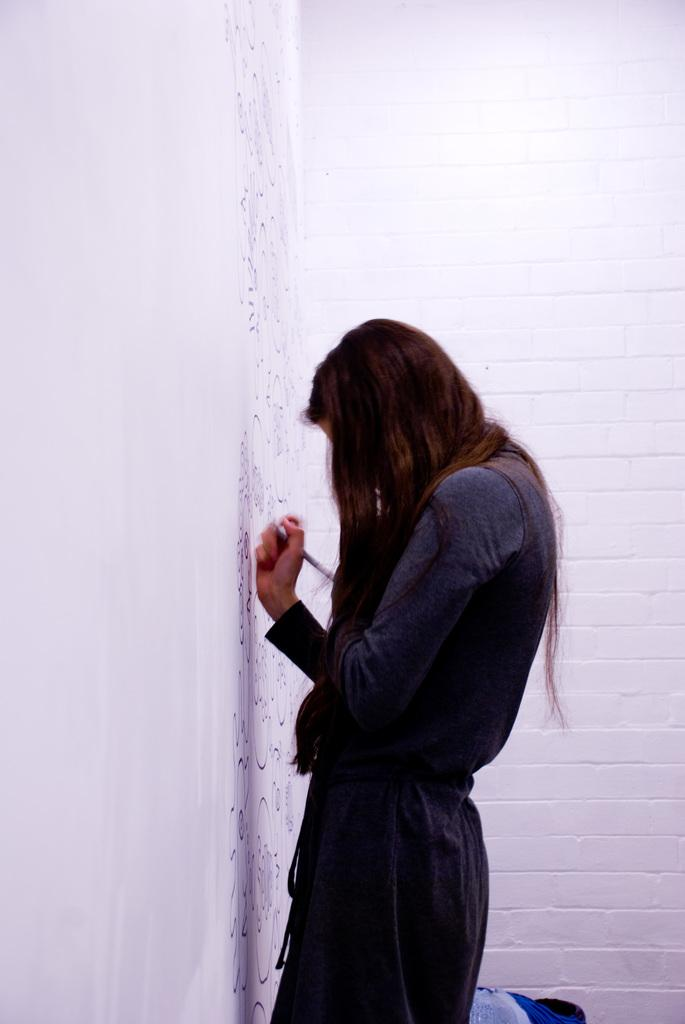Who is present in the image? There is a woman in the image. What is the woman doing in the image? The woman is standing at a wall and holding a pen. What can be seen in the background of the image? There is a wall in the background of the image. What type of bun is the woman eating in the image? There is no bun present in the image; the woman is holding a pen and standing at a wall. 